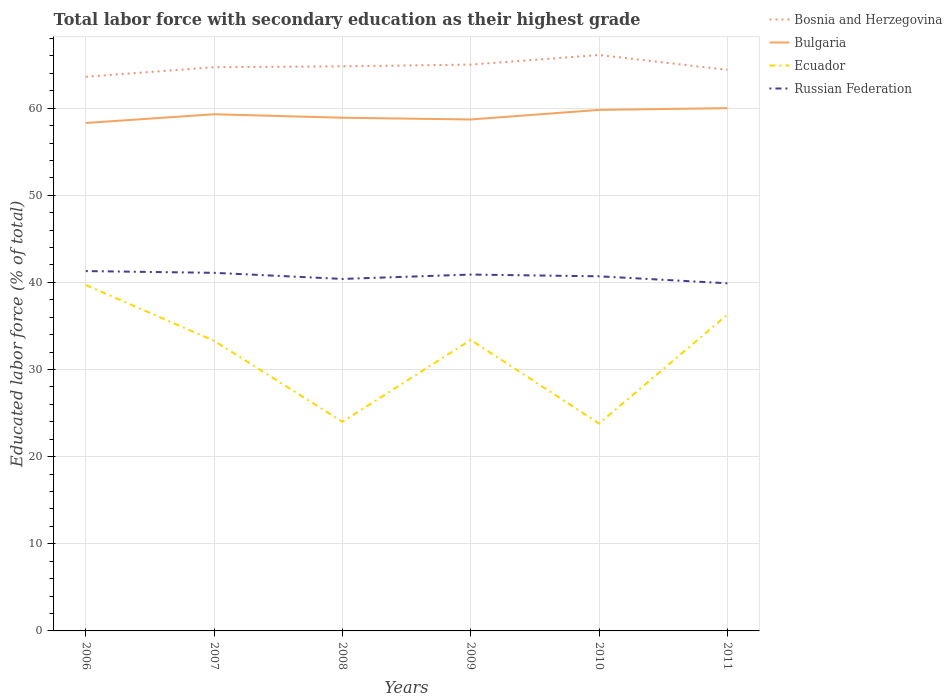Across all years, what is the maximum percentage of total labor force with primary education in Russian Federation?
Your answer should be compact. 39.9. What is the total percentage of total labor force with primary education in Russian Federation in the graph?
Your response must be concise. 0.2. What is the difference between the highest and the second highest percentage of total labor force with primary education in Ecuador?
Provide a succinct answer. 15.9. Is the percentage of total labor force with primary education in Bulgaria strictly greater than the percentage of total labor force with primary education in Bosnia and Herzegovina over the years?
Offer a very short reply. Yes. How many lines are there?
Your answer should be compact. 4. How many years are there in the graph?
Ensure brevity in your answer.  6. Are the values on the major ticks of Y-axis written in scientific E-notation?
Your response must be concise. No. Does the graph contain any zero values?
Give a very brief answer. No. Where does the legend appear in the graph?
Offer a very short reply. Top right. How many legend labels are there?
Offer a terse response. 4. How are the legend labels stacked?
Your response must be concise. Vertical. What is the title of the graph?
Provide a succinct answer. Total labor force with secondary education as their highest grade. What is the label or title of the Y-axis?
Your answer should be compact. Educated labor force (% of total). What is the Educated labor force (% of total) of Bosnia and Herzegovina in 2006?
Keep it short and to the point. 63.6. What is the Educated labor force (% of total) in Bulgaria in 2006?
Offer a terse response. 58.3. What is the Educated labor force (% of total) in Ecuador in 2006?
Give a very brief answer. 39.7. What is the Educated labor force (% of total) in Russian Federation in 2006?
Provide a succinct answer. 41.3. What is the Educated labor force (% of total) of Bosnia and Herzegovina in 2007?
Give a very brief answer. 64.7. What is the Educated labor force (% of total) in Bulgaria in 2007?
Provide a short and direct response. 59.3. What is the Educated labor force (% of total) of Ecuador in 2007?
Your response must be concise. 33.3. What is the Educated labor force (% of total) of Russian Federation in 2007?
Ensure brevity in your answer.  41.1. What is the Educated labor force (% of total) of Bosnia and Herzegovina in 2008?
Provide a short and direct response. 64.8. What is the Educated labor force (% of total) in Bulgaria in 2008?
Provide a short and direct response. 58.9. What is the Educated labor force (% of total) of Ecuador in 2008?
Provide a succinct answer. 24. What is the Educated labor force (% of total) in Russian Federation in 2008?
Your answer should be compact. 40.4. What is the Educated labor force (% of total) of Bulgaria in 2009?
Offer a terse response. 58.7. What is the Educated labor force (% of total) of Ecuador in 2009?
Provide a succinct answer. 33.4. What is the Educated labor force (% of total) in Russian Federation in 2009?
Provide a short and direct response. 40.9. What is the Educated labor force (% of total) of Bosnia and Herzegovina in 2010?
Your answer should be very brief. 66.1. What is the Educated labor force (% of total) in Bulgaria in 2010?
Offer a very short reply. 59.8. What is the Educated labor force (% of total) in Ecuador in 2010?
Offer a very short reply. 23.8. What is the Educated labor force (% of total) of Russian Federation in 2010?
Give a very brief answer. 40.7. What is the Educated labor force (% of total) of Bosnia and Herzegovina in 2011?
Offer a very short reply. 64.4. What is the Educated labor force (% of total) in Bulgaria in 2011?
Provide a succinct answer. 60. What is the Educated labor force (% of total) in Ecuador in 2011?
Your response must be concise. 36.3. What is the Educated labor force (% of total) in Russian Federation in 2011?
Give a very brief answer. 39.9. Across all years, what is the maximum Educated labor force (% of total) of Bosnia and Herzegovina?
Offer a terse response. 66.1. Across all years, what is the maximum Educated labor force (% of total) of Bulgaria?
Offer a terse response. 60. Across all years, what is the maximum Educated labor force (% of total) of Ecuador?
Make the answer very short. 39.7. Across all years, what is the maximum Educated labor force (% of total) of Russian Federation?
Provide a short and direct response. 41.3. Across all years, what is the minimum Educated labor force (% of total) in Bosnia and Herzegovina?
Provide a succinct answer. 63.6. Across all years, what is the minimum Educated labor force (% of total) of Bulgaria?
Provide a succinct answer. 58.3. Across all years, what is the minimum Educated labor force (% of total) of Ecuador?
Provide a short and direct response. 23.8. Across all years, what is the minimum Educated labor force (% of total) in Russian Federation?
Make the answer very short. 39.9. What is the total Educated labor force (% of total) of Bosnia and Herzegovina in the graph?
Your answer should be very brief. 388.6. What is the total Educated labor force (% of total) of Bulgaria in the graph?
Provide a short and direct response. 355. What is the total Educated labor force (% of total) of Ecuador in the graph?
Your answer should be compact. 190.5. What is the total Educated labor force (% of total) in Russian Federation in the graph?
Provide a succinct answer. 244.3. What is the difference between the Educated labor force (% of total) of Bosnia and Herzegovina in 2006 and that in 2007?
Give a very brief answer. -1.1. What is the difference between the Educated labor force (% of total) of Russian Federation in 2006 and that in 2008?
Provide a succinct answer. 0.9. What is the difference between the Educated labor force (% of total) of Russian Federation in 2006 and that in 2009?
Provide a short and direct response. 0.4. What is the difference between the Educated labor force (% of total) of Bulgaria in 2006 and that in 2010?
Your answer should be very brief. -1.5. What is the difference between the Educated labor force (% of total) of Ecuador in 2006 and that in 2010?
Keep it short and to the point. 15.9. What is the difference between the Educated labor force (% of total) in Bulgaria in 2006 and that in 2011?
Offer a terse response. -1.7. What is the difference between the Educated labor force (% of total) of Bosnia and Herzegovina in 2007 and that in 2008?
Make the answer very short. -0.1. What is the difference between the Educated labor force (% of total) of Bulgaria in 2007 and that in 2008?
Give a very brief answer. 0.4. What is the difference between the Educated labor force (% of total) in Ecuador in 2007 and that in 2008?
Your response must be concise. 9.3. What is the difference between the Educated labor force (% of total) of Russian Federation in 2007 and that in 2008?
Your response must be concise. 0.7. What is the difference between the Educated labor force (% of total) in Ecuador in 2007 and that in 2009?
Ensure brevity in your answer.  -0.1. What is the difference between the Educated labor force (% of total) of Russian Federation in 2007 and that in 2009?
Your answer should be very brief. 0.2. What is the difference between the Educated labor force (% of total) of Bosnia and Herzegovina in 2007 and that in 2010?
Your answer should be compact. -1.4. What is the difference between the Educated labor force (% of total) of Bulgaria in 2007 and that in 2011?
Give a very brief answer. -0.7. What is the difference between the Educated labor force (% of total) of Russian Federation in 2007 and that in 2011?
Keep it short and to the point. 1.2. What is the difference between the Educated labor force (% of total) of Bosnia and Herzegovina in 2008 and that in 2009?
Offer a terse response. -0.2. What is the difference between the Educated labor force (% of total) in Bulgaria in 2008 and that in 2009?
Keep it short and to the point. 0.2. What is the difference between the Educated labor force (% of total) of Russian Federation in 2008 and that in 2009?
Make the answer very short. -0.5. What is the difference between the Educated labor force (% of total) in Ecuador in 2008 and that in 2010?
Offer a very short reply. 0.2. What is the difference between the Educated labor force (% of total) of Bulgaria in 2008 and that in 2011?
Offer a very short reply. -1.1. What is the difference between the Educated labor force (% of total) in Ecuador in 2008 and that in 2011?
Provide a succinct answer. -12.3. What is the difference between the Educated labor force (% of total) of Bulgaria in 2009 and that in 2010?
Offer a very short reply. -1.1. What is the difference between the Educated labor force (% of total) of Bulgaria in 2010 and that in 2011?
Provide a succinct answer. -0.2. What is the difference between the Educated labor force (% of total) in Ecuador in 2010 and that in 2011?
Your answer should be very brief. -12.5. What is the difference between the Educated labor force (% of total) in Bosnia and Herzegovina in 2006 and the Educated labor force (% of total) in Ecuador in 2007?
Give a very brief answer. 30.3. What is the difference between the Educated labor force (% of total) in Bosnia and Herzegovina in 2006 and the Educated labor force (% of total) in Russian Federation in 2007?
Your answer should be compact. 22.5. What is the difference between the Educated labor force (% of total) of Bulgaria in 2006 and the Educated labor force (% of total) of Ecuador in 2007?
Your answer should be very brief. 25. What is the difference between the Educated labor force (% of total) in Ecuador in 2006 and the Educated labor force (% of total) in Russian Federation in 2007?
Ensure brevity in your answer.  -1.4. What is the difference between the Educated labor force (% of total) of Bosnia and Herzegovina in 2006 and the Educated labor force (% of total) of Ecuador in 2008?
Your response must be concise. 39.6. What is the difference between the Educated labor force (% of total) in Bosnia and Herzegovina in 2006 and the Educated labor force (% of total) in Russian Federation in 2008?
Your response must be concise. 23.2. What is the difference between the Educated labor force (% of total) of Bulgaria in 2006 and the Educated labor force (% of total) of Ecuador in 2008?
Your answer should be compact. 34.3. What is the difference between the Educated labor force (% of total) of Bosnia and Herzegovina in 2006 and the Educated labor force (% of total) of Ecuador in 2009?
Give a very brief answer. 30.2. What is the difference between the Educated labor force (% of total) in Bosnia and Herzegovina in 2006 and the Educated labor force (% of total) in Russian Federation in 2009?
Provide a short and direct response. 22.7. What is the difference between the Educated labor force (% of total) in Bulgaria in 2006 and the Educated labor force (% of total) in Ecuador in 2009?
Make the answer very short. 24.9. What is the difference between the Educated labor force (% of total) of Bosnia and Herzegovina in 2006 and the Educated labor force (% of total) of Ecuador in 2010?
Provide a succinct answer. 39.8. What is the difference between the Educated labor force (% of total) in Bosnia and Herzegovina in 2006 and the Educated labor force (% of total) in Russian Federation in 2010?
Give a very brief answer. 22.9. What is the difference between the Educated labor force (% of total) in Bulgaria in 2006 and the Educated labor force (% of total) in Ecuador in 2010?
Give a very brief answer. 34.5. What is the difference between the Educated labor force (% of total) in Bulgaria in 2006 and the Educated labor force (% of total) in Russian Federation in 2010?
Offer a very short reply. 17.6. What is the difference between the Educated labor force (% of total) of Ecuador in 2006 and the Educated labor force (% of total) of Russian Federation in 2010?
Make the answer very short. -1. What is the difference between the Educated labor force (% of total) in Bosnia and Herzegovina in 2006 and the Educated labor force (% of total) in Ecuador in 2011?
Your answer should be compact. 27.3. What is the difference between the Educated labor force (% of total) in Bosnia and Herzegovina in 2006 and the Educated labor force (% of total) in Russian Federation in 2011?
Offer a very short reply. 23.7. What is the difference between the Educated labor force (% of total) in Bulgaria in 2006 and the Educated labor force (% of total) in Ecuador in 2011?
Make the answer very short. 22. What is the difference between the Educated labor force (% of total) in Bosnia and Herzegovina in 2007 and the Educated labor force (% of total) in Bulgaria in 2008?
Provide a succinct answer. 5.8. What is the difference between the Educated labor force (% of total) in Bosnia and Herzegovina in 2007 and the Educated labor force (% of total) in Ecuador in 2008?
Offer a terse response. 40.7. What is the difference between the Educated labor force (% of total) of Bosnia and Herzegovina in 2007 and the Educated labor force (% of total) of Russian Federation in 2008?
Ensure brevity in your answer.  24.3. What is the difference between the Educated labor force (% of total) in Bulgaria in 2007 and the Educated labor force (% of total) in Ecuador in 2008?
Keep it short and to the point. 35.3. What is the difference between the Educated labor force (% of total) in Bosnia and Herzegovina in 2007 and the Educated labor force (% of total) in Bulgaria in 2009?
Offer a terse response. 6. What is the difference between the Educated labor force (% of total) in Bosnia and Herzegovina in 2007 and the Educated labor force (% of total) in Ecuador in 2009?
Provide a short and direct response. 31.3. What is the difference between the Educated labor force (% of total) of Bosnia and Herzegovina in 2007 and the Educated labor force (% of total) of Russian Federation in 2009?
Give a very brief answer. 23.8. What is the difference between the Educated labor force (% of total) of Bulgaria in 2007 and the Educated labor force (% of total) of Ecuador in 2009?
Ensure brevity in your answer.  25.9. What is the difference between the Educated labor force (% of total) in Bulgaria in 2007 and the Educated labor force (% of total) in Russian Federation in 2009?
Offer a very short reply. 18.4. What is the difference between the Educated labor force (% of total) in Bosnia and Herzegovina in 2007 and the Educated labor force (% of total) in Ecuador in 2010?
Keep it short and to the point. 40.9. What is the difference between the Educated labor force (% of total) in Bulgaria in 2007 and the Educated labor force (% of total) in Ecuador in 2010?
Keep it short and to the point. 35.5. What is the difference between the Educated labor force (% of total) of Bulgaria in 2007 and the Educated labor force (% of total) of Russian Federation in 2010?
Your response must be concise. 18.6. What is the difference between the Educated labor force (% of total) of Bosnia and Herzegovina in 2007 and the Educated labor force (% of total) of Ecuador in 2011?
Give a very brief answer. 28.4. What is the difference between the Educated labor force (% of total) of Bosnia and Herzegovina in 2007 and the Educated labor force (% of total) of Russian Federation in 2011?
Provide a succinct answer. 24.8. What is the difference between the Educated labor force (% of total) of Bulgaria in 2007 and the Educated labor force (% of total) of Russian Federation in 2011?
Give a very brief answer. 19.4. What is the difference between the Educated labor force (% of total) of Bosnia and Herzegovina in 2008 and the Educated labor force (% of total) of Bulgaria in 2009?
Ensure brevity in your answer.  6.1. What is the difference between the Educated labor force (% of total) of Bosnia and Herzegovina in 2008 and the Educated labor force (% of total) of Ecuador in 2009?
Provide a succinct answer. 31.4. What is the difference between the Educated labor force (% of total) of Bosnia and Herzegovina in 2008 and the Educated labor force (% of total) of Russian Federation in 2009?
Provide a short and direct response. 23.9. What is the difference between the Educated labor force (% of total) of Bulgaria in 2008 and the Educated labor force (% of total) of Russian Federation in 2009?
Make the answer very short. 18. What is the difference between the Educated labor force (% of total) of Ecuador in 2008 and the Educated labor force (% of total) of Russian Federation in 2009?
Keep it short and to the point. -16.9. What is the difference between the Educated labor force (% of total) in Bosnia and Herzegovina in 2008 and the Educated labor force (% of total) in Bulgaria in 2010?
Ensure brevity in your answer.  5. What is the difference between the Educated labor force (% of total) of Bosnia and Herzegovina in 2008 and the Educated labor force (% of total) of Russian Federation in 2010?
Your answer should be compact. 24.1. What is the difference between the Educated labor force (% of total) of Bulgaria in 2008 and the Educated labor force (% of total) of Ecuador in 2010?
Provide a succinct answer. 35.1. What is the difference between the Educated labor force (% of total) in Bulgaria in 2008 and the Educated labor force (% of total) in Russian Federation in 2010?
Provide a succinct answer. 18.2. What is the difference between the Educated labor force (% of total) in Ecuador in 2008 and the Educated labor force (% of total) in Russian Federation in 2010?
Keep it short and to the point. -16.7. What is the difference between the Educated labor force (% of total) of Bosnia and Herzegovina in 2008 and the Educated labor force (% of total) of Ecuador in 2011?
Offer a terse response. 28.5. What is the difference between the Educated labor force (% of total) in Bosnia and Herzegovina in 2008 and the Educated labor force (% of total) in Russian Federation in 2011?
Ensure brevity in your answer.  24.9. What is the difference between the Educated labor force (% of total) in Bulgaria in 2008 and the Educated labor force (% of total) in Ecuador in 2011?
Offer a terse response. 22.6. What is the difference between the Educated labor force (% of total) of Bulgaria in 2008 and the Educated labor force (% of total) of Russian Federation in 2011?
Your answer should be very brief. 19. What is the difference between the Educated labor force (% of total) in Ecuador in 2008 and the Educated labor force (% of total) in Russian Federation in 2011?
Your response must be concise. -15.9. What is the difference between the Educated labor force (% of total) of Bosnia and Herzegovina in 2009 and the Educated labor force (% of total) of Ecuador in 2010?
Your answer should be very brief. 41.2. What is the difference between the Educated labor force (% of total) of Bosnia and Herzegovina in 2009 and the Educated labor force (% of total) of Russian Federation in 2010?
Your answer should be very brief. 24.3. What is the difference between the Educated labor force (% of total) of Bulgaria in 2009 and the Educated labor force (% of total) of Ecuador in 2010?
Your response must be concise. 34.9. What is the difference between the Educated labor force (% of total) of Bosnia and Herzegovina in 2009 and the Educated labor force (% of total) of Ecuador in 2011?
Provide a short and direct response. 28.7. What is the difference between the Educated labor force (% of total) in Bosnia and Herzegovina in 2009 and the Educated labor force (% of total) in Russian Federation in 2011?
Offer a terse response. 25.1. What is the difference between the Educated labor force (% of total) in Bulgaria in 2009 and the Educated labor force (% of total) in Ecuador in 2011?
Provide a succinct answer. 22.4. What is the difference between the Educated labor force (% of total) in Bosnia and Herzegovina in 2010 and the Educated labor force (% of total) in Ecuador in 2011?
Offer a terse response. 29.8. What is the difference between the Educated labor force (% of total) of Bosnia and Herzegovina in 2010 and the Educated labor force (% of total) of Russian Federation in 2011?
Ensure brevity in your answer.  26.2. What is the difference between the Educated labor force (% of total) of Bulgaria in 2010 and the Educated labor force (% of total) of Ecuador in 2011?
Offer a terse response. 23.5. What is the difference between the Educated labor force (% of total) of Ecuador in 2010 and the Educated labor force (% of total) of Russian Federation in 2011?
Offer a very short reply. -16.1. What is the average Educated labor force (% of total) in Bosnia and Herzegovina per year?
Provide a short and direct response. 64.77. What is the average Educated labor force (% of total) in Bulgaria per year?
Give a very brief answer. 59.17. What is the average Educated labor force (% of total) in Ecuador per year?
Your answer should be compact. 31.75. What is the average Educated labor force (% of total) in Russian Federation per year?
Ensure brevity in your answer.  40.72. In the year 2006, what is the difference between the Educated labor force (% of total) in Bosnia and Herzegovina and Educated labor force (% of total) in Ecuador?
Your answer should be very brief. 23.9. In the year 2006, what is the difference between the Educated labor force (% of total) in Bosnia and Herzegovina and Educated labor force (% of total) in Russian Federation?
Ensure brevity in your answer.  22.3. In the year 2006, what is the difference between the Educated labor force (% of total) of Bulgaria and Educated labor force (% of total) of Russian Federation?
Give a very brief answer. 17. In the year 2007, what is the difference between the Educated labor force (% of total) in Bosnia and Herzegovina and Educated labor force (% of total) in Bulgaria?
Offer a very short reply. 5.4. In the year 2007, what is the difference between the Educated labor force (% of total) in Bosnia and Herzegovina and Educated labor force (% of total) in Ecuador?
Offer a terse response. 31.4. In the year 2007, what is the difference between the Educated labor force (% of total) in Bosnia and Herzegovina and Educated labor force (% of total) in Russian Federation?
Your answer should be very brief. 23.6. In the year 2007, what is the difference between the Educated labor force (% of total) in Bulgaria and Educated labor force (% of total) in Russian Federation?
Make the answer very short. 18.2. In the year 2008, what is the difference between the Educated labor force (% of total) in Bosnia and Herzegovina and Educated labor force (% of total) in Ecuador?
Provide a short and direct response. 40.8. In the year 2008, what is the difference between the Educated labor force (% of total) in Bosnia and Herzegovina and Educated labor force (% of total) in Russian Federation?
Your response must be concise. 24.4. In the year 2008, what is the difference between the Educated labor force (% of total) of Bulgaria and Educated labor force (% of total) of Ecuador?
Provide a short and direct response. 34.9. In the year 2008, what is the difference between the Educated labor force (% of total) of Ecuador and Educated labor force (% of total) of Russian Federation?
Your answer should be very brief. -16.4. In the year 2009, what is the difference between the Educated labor force (% of total) of Bosnia and Herzegovina and Educated labor force (% of total) of Bulgaria?
Your answer should be very brief. 6.3. In the year 2009, what is the difference between the Educated labor force (% of total) of Bosnia and Herzegovina and Educated labor force (% of total) of Ecuador?
Your response must be concise. 31.6. In the year 2009, what is the difference between the Educated labor force (% of total) of Bosnia and Herzegovina and Educated labor force (% of total) of Russian Federation?
Provide a succinct answer. 24.1. In the year 2009, what is the difference between the Educated labor force (% of total) in Bulgaria and Educated labor force (% of total) in Ecuador?
Your response must be concise. 25.3. In the year 2009, what is the difference between the Educated labor force (% of total) in Bulgaria and Educated labor force (% of total) in Russian Federation?
Make the answer very short. 17.8. In the year 2009, what is the difference between the Educated labor force (% of total) of Ecuador and Educated labor force (% of total) of Russian Federation?
Ensure brevity in your answer.  -7.5. In the year 2010, what is the difference between the Educated labor force (% of total) in Bosnia and Herzegovina and Educated labor force (% of total) in Ecuador?
Offer a terse response. 42.3. In the year 2010, what is the difference between the Educated labor force (% of total) in Bosnia and Herzegovina and Educated labor force (% of total) in Russian Federation?
Your answer should be very brief. 25.4. In the year 2010, what is the difference between the Educated labor force (% of total) in Bulgaria and Educated labor force (% of total) in Russian Federation?
Your answer should be very brief. 19.1. In the year 2010, what is the difference between the Educated labor force (% of total) of Ecuador and Educated labor force (% of total) of Russian Federation?
Give a very brief answer. -16.9. In the year 2011, what is the difference between the Educated labor force (% of total) in Bosnia and Herzegovina and Educated labor force (% of total) in Ecuador?
Provide a short and direct response. 28.1. In the year 2011, what is the difference between the Educated labor force (% of total) of Bulgaria and Educated labor force (% of total) of Ecuador?
Provide a short and direct response. 23.7. In the year 2011, what is the difference between the Educated labor force (% of total) of Bulgaria and Educated labor force (% of total) of Russian Federation?
Ensure brevity in your answer.  20.1. In the year 2011, what is the difference between the Educated labor force (% of total) in Ecuador and Educated labor force (% of total) in Russian Federation?
Make the answer very short. -3.6. What is the ratio of the Educated labor force (% of total) in Bosnia and Herzegovina in 2006 to that in 2007?
Your response must be concise. 0.98. What is the ratio of the Educated labor force (% of total) of Bulgaria in 2006 to that in 2007?
Offer a very short reply. 0.98. What is the ratio of the Educated labor force (% of total) in Ecuador in 2006 to that in 2007?
Your response must be concise. 1.19. What is the ratio of the Educated labor force (% of total) in Bosnia and Herzegovina in 2006 to that in 2008?
Provide a short and direct response. 0.98. What is the ratio of the Educated labor force (% of total) of Bulgaria in 2006 to that in 2008?
Offer a very short reply. 0.99. What is the ratio of the Educated labor force (% of total) of Ecuador in 2006 to that in 2008?
Offer a very short reply. 1.65. What is the ratio of the Educated labor force (% of total) in Russian Federation in 2006 to that in 2008?
Make the answer very short. 1.02. What is the ratio of the Educated labor force (% of total) in Bosnia and Herzegovina in 2006 to that in 2009?
Provide a succinct answer. 0.98. What is the ratio of the Educated labor force (% of total) of Ecuador in 2006 to that in 2009?
Offer a terse response. 1.19. What is the ratio of the Educated labor force (% of total) in Russian Federation in 2006 to that in 2009?
Provide a short and direct response. 1.01. What is the ratio of the Educated labor force (% of total) in Bosnia and Herzegovina in 2006 to that in 2010?
Make the answer very short. 0.96. What is the ratio of the Educated labor force (% of total) of Bulgaria in 2006 to that in 2010?
Keep it short and to the point. 0.97. What is the ratio of the Educated labor force (% of total) of Ecuador in 2006 to that in 2010?
Offer a very short reply. 1.67. What is the ratio of the Educated labor force (% of total) in Russian Federation in 2006 to that in 2010?
Your answer should be compact. 1.01. What is the ratio of the Educated labor force (% of total) of Bosnia and Herzegovina in 2006 to that in 2011?
Keep it short and to the point. 0.99. What is the ratio of the Educated labor force (% of total) of Bulgaria in 2006 to that in 2011?
Keep it short and to the point. 0.97. What is the ratio of the Educated labor force (% of total) in Ecuador in 2006 to that in 2011?
Ensure brevity in your answer.  1.09. What is the ratio of the Educated labor force (% of total) of Russian Federation in 2006 to that in 2011?
Your answer should be compact. 1.04. What is the ratio of the Educated labor force (% of total) in Bosnia and Herzegovina in 2007 to that in 2008?
Offer a terse response. 1. What is the ratio of the Educated labor force (% of total) of Bulgaria in 2007 to that in 2008?
Offer a very short reply. 1.01. What is the ratio of the Educated labor force (% of total) of Ecuador in 2007 to that in 2008?
Offer a very short reply. 1.39. What is the ratio of the Educated labor force (% of total) in Russian Federation in 2007 to that in 2008?
Provide a succinct answer. 1.02. What is the ratio of the Educated labor force (% of total) of Bulgaria in 2007 to that in 2009?
Your response must be concise. 1.01. What is the ratio of the Educated labor force (% of total) in Bosnia and Herzegovina in 2007 to that in 2010?
Provide a short and direct response. 0.98. What is the ratio of the Educated labor force (% of total) in Ecuador in 2007 to that in 2010?
Make the answer very short. 1.4. What is the ratio of the Educated labor force (% of total) in Russian Federation in 2007 to that in 2010?
Your answer should be very brief. 1.01. What is the ratio of the Educated labor force (% of total) of Bosnia and Herzegovina in 2007 to that in 2011?
Keep it short and to the point. 1. What is the ratio of the Educated labor force (% of total) in Bulgaria in 2007 to that in 2011?
Make the answer very short. 0.99. What is the ratio of the Educated labor force (% of total) in Ecuador in 2007 to that in 2011?
Ensure brevity in your answer.  0.92. What is the ratio of the Educated labor force (% of total) in Russian Federation in 2007 to that in 2011?
Offer a terse response. 1.03. What is the ratio of the Educated labor force (% of total) of Ecuador in 2008 to that in 2009?
Provide a succinct answer. 0.72. What is the ratio of the Educated labor force (% of total) in Bosnia and Herzegovina in 2008 to that in 2010?
Keep it short and to the point. 0.98. What is the ratio of the Educated labor force (% of total) in Bulgaria in 2008 to that in 2010?
Ensure brevity in your answer.  0.98. What is the ratio of the Educated labor force (% of total) in Ecuador in 2008 to that in 2010?
Provide a succinct answer. 1.01. What is the ratio of the Educated labor force (% of total) of Bosnia and Herzegovina in 2008 to that in 2011?
Offer a terse response. 1.01. What is the ratio of the Educated labor force (% of total) of Bulgaria in 2008 to that in 2011?
Ensure brevity in your answer.  0.98. What is the ratio of the Educated labor force (% of total) of Ecuador in 2008 to that in 2011?
Your answer should be very brief. 0.66. What is the ratio of the Educated labor force (% of total) of Russian Federation in 2008 to that in 2011?
Make the answer very short. 1.01. What is the ratio of the Educated labor force (% of total) in Bosnia and Herzegovina in 2009 to that in 2010?
Provide a succinct answer. 0.98. What is the ratio of the Educated labor force (% of total) of Bulgaria in 2009 to that in 2010?
Your answer should be very brief. 0.98. What is the ratio of the Educated labor force (% of total) in Ecuador in 2009 to that in 2010?
Offer a terse response. 1.4. What is the ratio of the Educated labor force (% of total) of Russian Federation in 2009 to that in 2010?
Your answer should be compact. 1. What is the ratio of the Educated labor force (% of total) of Bosnia and Herzegovina in 2009 to that in 2011?
Your response must be concise. 1.01. What is the ratio of the Educated labor force (% of total) in Bulgaria in 2009 to that in 2011?
Keep it short and to the point. 0.98. What is the ratio of the Educated labor force (% of total) of Ecuador in 2009 to that in 2011?
Your response must be concise. 0.92. What is the ratio of the Educated labor force (% of total) of Russian Federation in 2009 to that in 2011?
Your answer should be compact. 1.03. What is the ratio of the Educated labor force (% of total) in Bosnia and Herzegovina in 2010 to that in 2011?
Ensure brevity in your answer.  1.03. What is the ratio of the Educated labor force (% of total) of Ecuador in 2010 to that in 2011?
Keep it short and to the point. 0.66. What is the ratio of the Educated labor force (% of total) in Russian Federation in 2010 to that in 2011?
Your response must be concise. 1.02. What is the difference between the highest and the second highest Educated labor force (% of total) in Bosnia and Herzegovina?
Provide a short and direct response. 1.1. What is the difference between the highest and the second highest Educated labor force (% of total) of Bulgaria?
Offer a very short reply. 0.2. What is the difference between the highest and the lowest Educated labor force (% of total) of Bosnia and Herzegovina?
Make the answer very short. 2.5. What is the difference between the highest and the lowest Educated labor force (% of total) in Bulgaria?
Your response must be concise. 1.7. What is the difference between the highest and the lowest Educated labor force (% of total) of Ecuador?
Give a very brief answer. 15.9. 